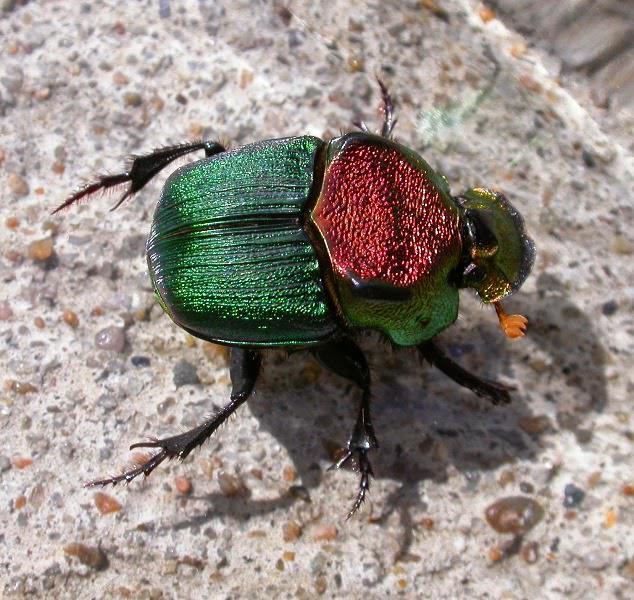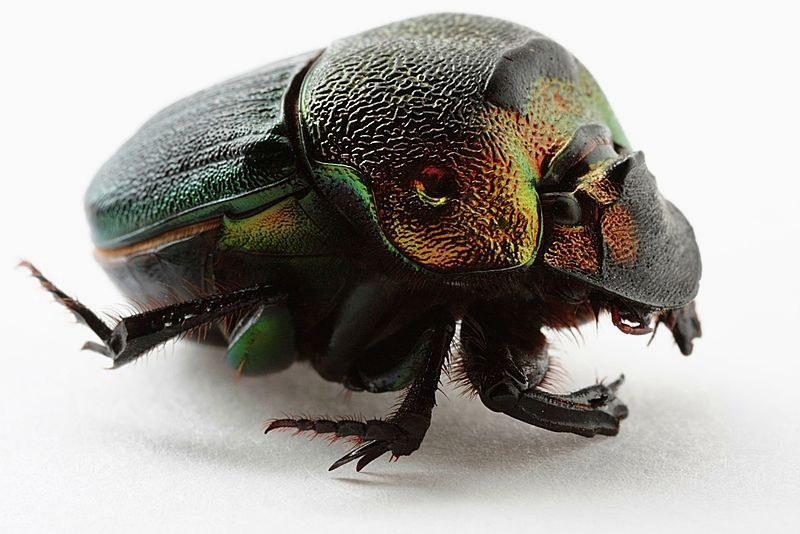The first image is the image on the left, the second image is the image on the right. Evaluate the accuracy of this statement regarding the images: "There is at least one black spot on the back of the insect in one of the images.". Is it true? Answer yes or no. No. 